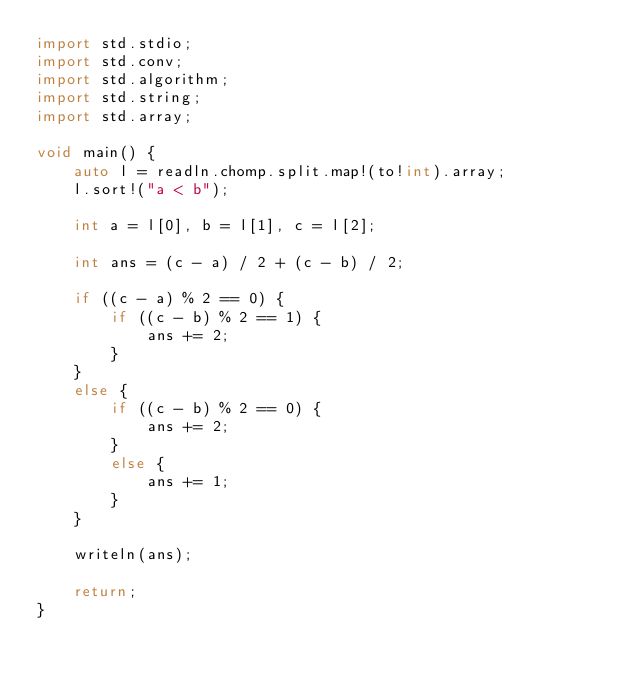Convert code to text. <code><loc_0><loc_0><loc_500><loc_500><_D_>import std.stdio;
import std.conv;
import std.algorithm;
import std.string;
import std.array;

void main() {
    auto l = readln.chomp.split.map!(to!int).array;
    l.sort!("a < b");

    int a = l[0], b = l[1], c = l[2];

    int ans = (c - a) / 2 + (c - b) / 2;

    if ((c - a) % 2 == 0) {
        if ((c - b) % 2 == 1) {
            ans += 2;
        }
    }
    else {
        if ((c - b) % 2 == 0) {
            ans += 2;
        }
        else {
            ans += 1;
        }
    }

    writeln(ans);

    return;
}</code> 